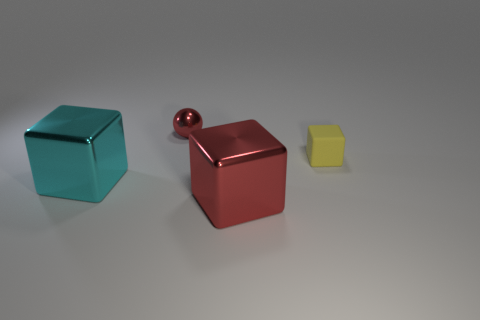What is the size of the other metallic thing that is the same color as the small metallic object?
Provide a succinct answer. Large. How many objects are either matte things or red things?
Make the answer very short. 3. What number of other things are the same size as the cyan thing?
Your answer should be compact. 1. There is a rubber cube; does it have the same color as the metal object right of the tiny metal thing?
Offer a terse response. No. What number of cylinders are large metallic things or metallic objects?
Your response must be concise. 0. Are there any other things that have the same color as the tiny metallic sphere?
Give a very brief answer. Yes. There is a cube right of the metallic block in front of the big cyan cube; what is it made of?
Offer a very short reply. Rubber. Are the cyan object and the small object on the right side of the tiny red object made of the same material?
Make the answer very short. No. What number of objects are metal cubes right of the cyan thing or small yellow cylinders?
Make the answer very short. 1. Is there a large shiny cube of the same color as the tiny ball?
Ensure brevity in your answer.  Yes. 